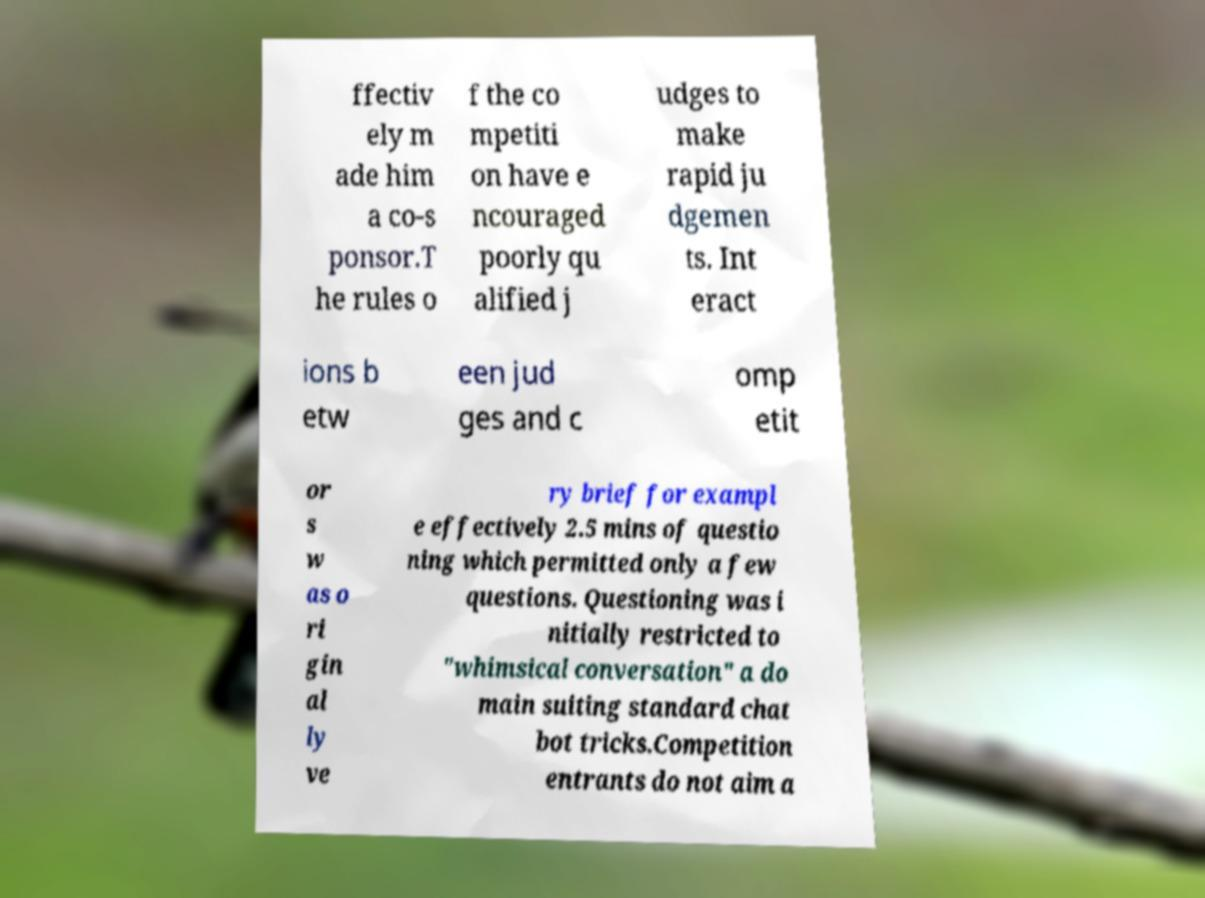Can you accurately transcribe the text from the provided image for me? ffectiv ely m ade him a co-s ponsor.T he rules o f the co mpetiti on have e ncouraged poorly qu alified j udges to make rapid ju dgemen ts. Int eract ions b etw een jud ges and c omp etit or s w as o ri gin al ly ve ry brief for exampl e effectively 2.5 mins of questio ning which permitted only a few questions. Questioning was i nitially restricted to "whimsical conversation" a do main suiting standard chat bot tricks.Competition entrants do not aim a 